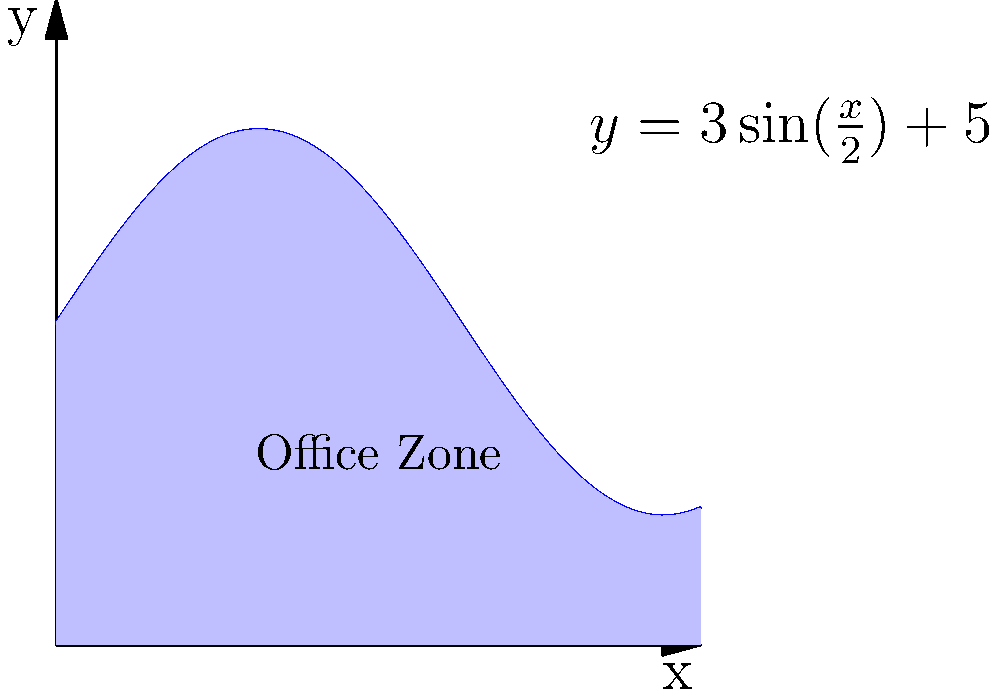As an HR manager, you're tasked with optimizing office space. The irregular shape of a new office zone can be modeled by the function $y = 3\sin(\frac{x}{2}) + 5$ from $x = 0$ to $x = 10$ (in meters). Calculate the area of this office zone to determine its capacity. Round your answer to the nearest whole number. To calculate the area of the irregularly shaped office zone, we need to use integration. Here's the step-by-step process:

1) The area under a curve from $a$ to $b$ is given by the definite integral:

   $$A = \int_{a}^{b} f(x) dx$$

2) In this case, $f(x) = 3\sin(\frac{x}{2}) + 5$, $a = 0$, and $b = 10$. So we have:

   $$A = \int_{0}^{10} (3\sin(\frac{x}{2}) + 5) dx$$

3) Let's split this integral:

   $$A = \int_{0}^{10} 3\sin(\frac{x}{2}) dx + \int_{0}^{10} 5 dx$$

4) For the first integral, we can use the substitution $u = \frac{x}{2}$, $du = \frac{1}{2}dx$:

   $$\int_{0}^{10} 3\sin(\frac{x}{2}) dx = 6\int_{0}^{5} \sin(u) du = -6\cos(u)|_{0}^{5} = -6(\cos(5) - \cos(0)) = 6(1 - \cos(5))$$

5) The second integral is straightforward:

   $$\int_{0}^{10} 5 dx = 5x|_{0}^{10} = 50$$

6) Adding these together:

   $$A = 6(1 - \cos(5)) + 50 \approx 55.715$$

7) Rounding to the nearest whole number:

   $$A \approx 56$$

Therefore, the area of the office zone is approximately 56 square meters.
Answer: 56 square meters 